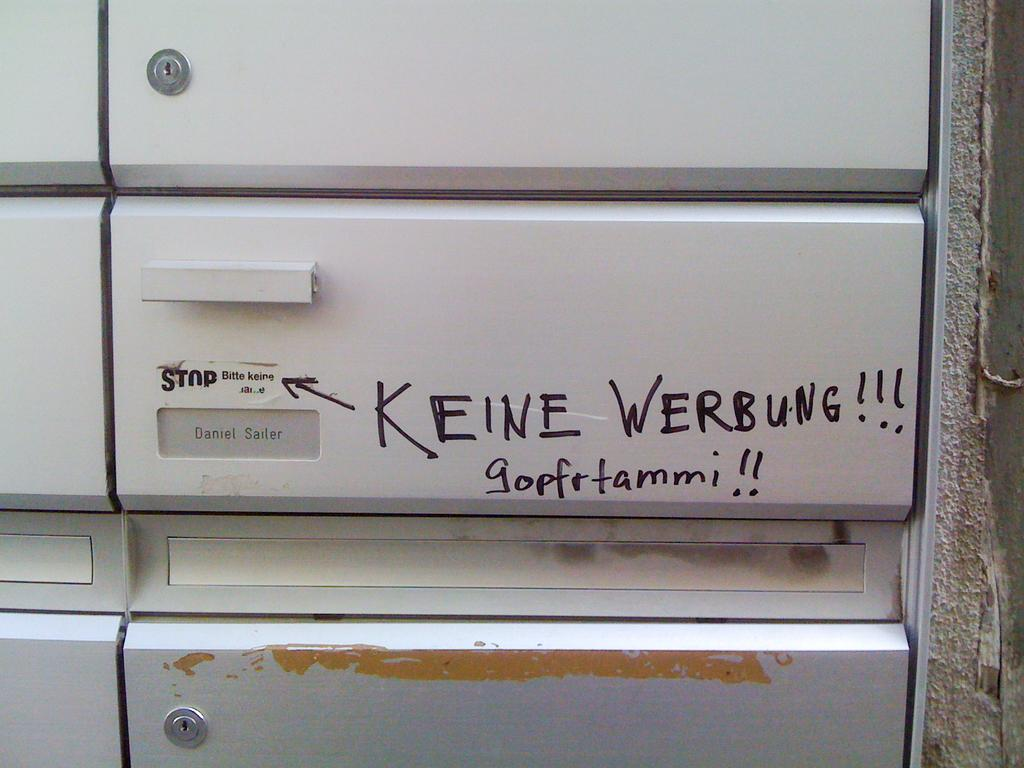What type of structure is present in the image? There are racks in the image. What is the color of the racks? The racks are white in color. What can be seen on the racks? There is text visible on the racks. What is visible on the right side of the image? There is a wall on the right side of the image. What type of agreement was reached at the plantation depicted in the image? There is no plantation or agreement mentioned in the image; it only features racks with text on them and a wall on the right side. 